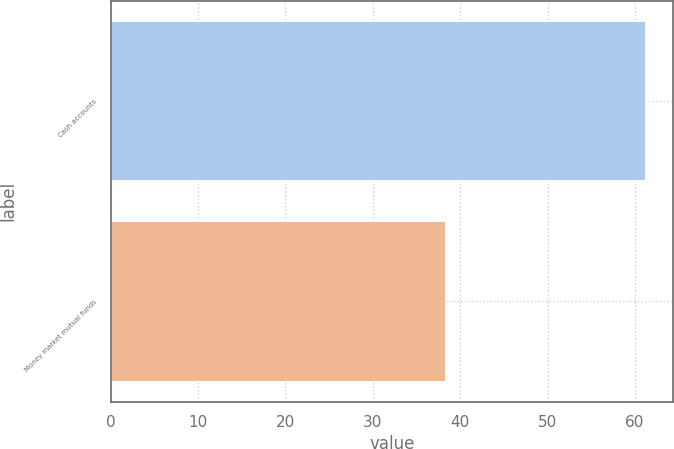Convert chart to OTSL. <chart><loc_0><loc_0><loc_500><loc_500><bar_chart><fcel>Cash accounts<fcel>Money market mutual funds<nl><fcel>61.3<fcel>38.4<nl></chart> 